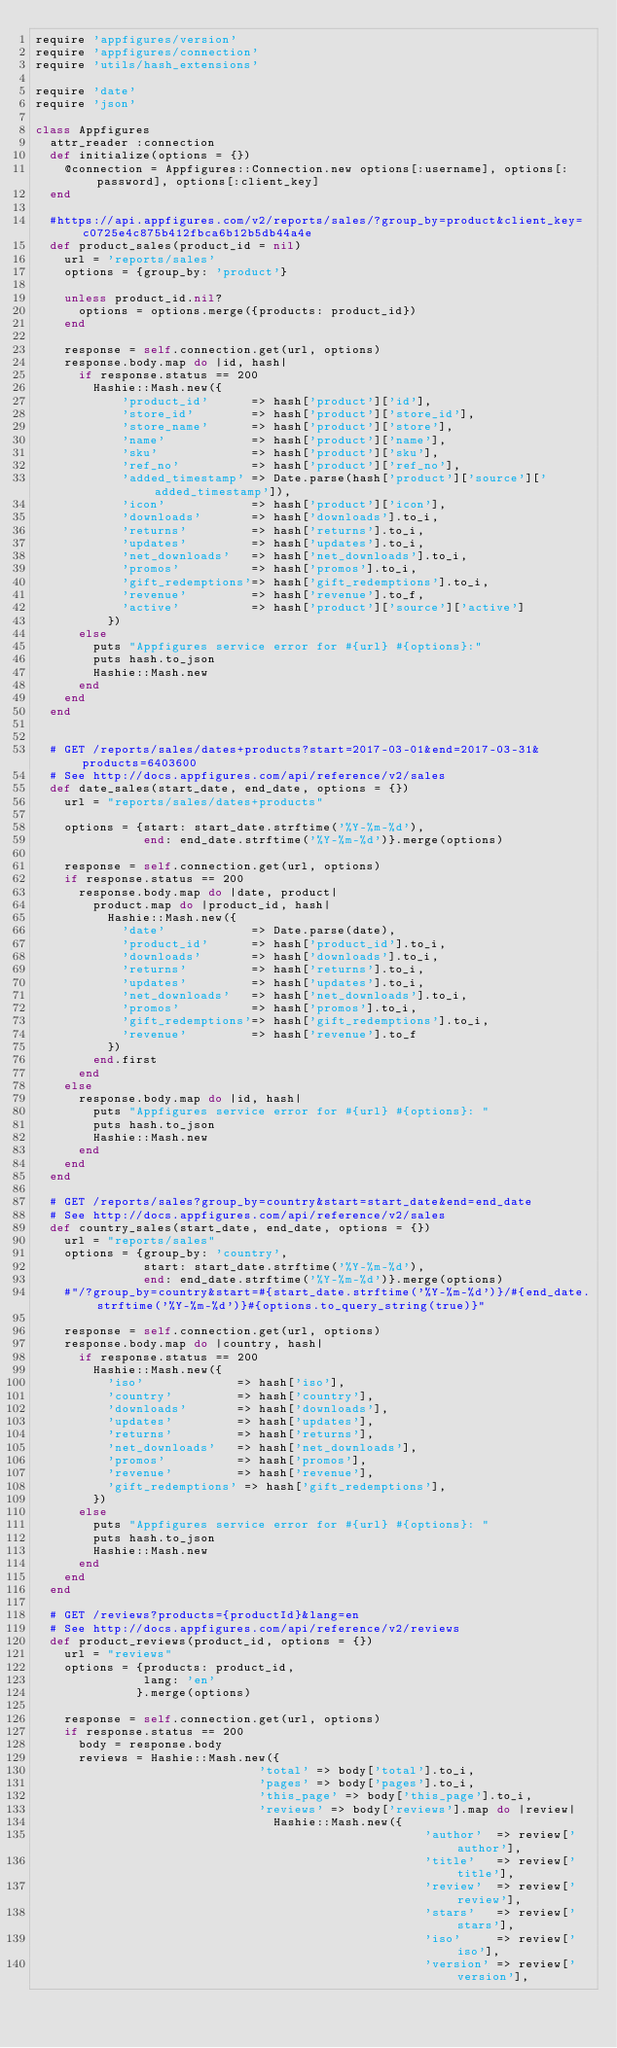Convert code to text. <code><loc_0><loc_0><loc_500><loc_500><_Ruby_>require 'appfigures/version'
require 'appfigures/connection'
require 'utils/hash_extensions'

require 'date'
require 'json'

class Appfigures
  attr_reader :connection
  def initialize(options = {})
    @connection = Appfigures::Connection.new options[:username], options[:password], options[:client_key]
  end

  #https://api.appfigures.com/v2/reports/sales/?group_by=product&client_key=c0725e4c875b412fbca6b12b5db44a4e
  def product_sales(product_id = nil)
    url = 'reports/sales'
    options = {group_by: 'product'}

    unless product_id.nil?
      options = options.merge({products: product_id})
    end

    response = self.connection.get(url, options)
    response.body.map do |id, hash|
      if response.status == 200
        Hashie::Mash.new({
            'product_id'      => hash['product']['id'],
            'store_id'        => hash['product']['store_id'],
            'store_name'      => hash['product']['store'],
            'name'            => hash['product']['name'],
            'sku'             => hash['product']['sku'],
            'ref_no'          => hash['product']['ref_no'],
            'added_timestamp' => Date.parse(hash['product']['source']['added_timestamp']),
            'icon'            => hash['product']['icon'],
            'downloads'       => hash['downloads'].to_i,
            'returns'         => hash['returns'].to_i,
            'updates'         => hash['updates'].to_i,
            'net_downloads'   => hash['net_downloads'].to_i,
            'promos'          => hash['promos'].to_i,
            'gift_redemptions'=> hash['gift_redemptions'].to_i,
            'revenue'         => hash['revenue'].to_f,
            'active'          => hash['product']['source']['active']
          })
      else
        puts "Appfigures service error for #{url} #{options}:"
        puts hash.to_json
        Hashie::Mash.new
      end
    end
  end


  # GET /reports/sales/dates+products?start=2017-03-01&end=2017-03-31&products=6403600
  # See http://docs.appfigures.com/api/reference/v2/sales
  def date_sales(start_date, end_date, options = {})
    url = "reports/sales/dates+products"

    options = {start: start_date.strftime('%Y-%m-%d'),
               end: end_date.strftime('%Y-%m-%d')}.merge(options)

    response = self.connection.get(url, options)
    if response.status == 200 
      response.body.map do |date, product|
        product.map do |product_id, hash|
          Hashie::Mash.new({
            'date'            => Date.parse(date),
            'product_id'      => hash['product_id'].to_i,
            'downloads'       => hash['downloads'].to_i,
            'returns'         => hash['returns'].to_i,
            'updates'         => hash['updates'].to_i,
            'net_downloads'   => hash['net_downloads'].to_i,
            'promos'          => hash['promos'].to_i,
            'gift_redemptions'=> hash['gift_redemptions'].to_i,
            'revenue'         => hash['revenue'].to_f
          })
        end.first
      end
    else
      response.body.map do |id, hash|
        puts "Appfigures service error for #{url} #{options}: "
        puts hash.to_json
        Hashie::Mash.new
      end
    end
  end

  # GET /reports/sales?group_by=country&start=start_date&end=end_date
  # See http://docs.appfigures.com/api/reference/v2/sales
  def country_sales(start_date, end_date, options = {})
    url = "reports/sales"
    options = {group_by: 'country',
               start: start_date.strftime('%Y-%m-%d'),
               end: end_date.strftime('%Y-%m-%d')}.merge(options)
    #"/?group_by=country&start=#{start_date.strftime('%Y-%m-%d')}/#{end_date.strftime('%Y-%m-%d')}#{options.to_query_string(true)}"
    
    response = self.connection.get(url, options)
    response.body.map do |country, hash|
      if response.status == 200 
        Hashie::Mash.new({
          'iso'             => hash['iso'],
          'country'         => hash['country'],
          'downloads'       => hash['downloads'],
          'updates'         => hash['updates'],
          'returns'         => hash['returns'],
          'net_downloads'   => hash['net_downloads'],
          'promos'          => hash['promos'],
          'revenue'         => hash['revenue'],
          'gift_redemptions' => hash['gift_redemptions'],
        })
      else
        puts "Appfigures service error for #{url} #{options}: "
        puts hash.to_json
        Hashie::Mash.new
      end
    end
  end

  # GET /reviews?products={productId}&lang=en
  # See http://docs.appfigures.com/api/reference/v2/reviews
  def product_reviews(product_id, options = {})
    url = "reviews"
    options = {products: product_id,
               lang: 'en'
              }.merge(options)

    response = self.connection.get(url, options)
    if response.status == 200
      body = response.body
      reviews = Hashie::Mash.new({
                               'total' => body['total'].to_i,
                               'pages' => body['pages'].to_i,
                               'this_page' => body['this_page'].to_i,
                               'reviews' => body['reviews'].map do |review|
                                 Hashie::Mash.new({
                                                      'author'  => review['author'],
                                                      'title'   => review['title'],
                                                      'review'  => review['review'],
                                                      'stars'   => review['stars'],
                                                      'iso'     => review['iso'],
                                                      'version' => review['version'],</code> 